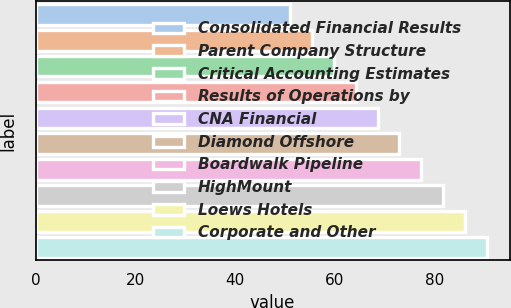<chart> <loc_0><loc_0><loc_500><loc_500><bar_chart><fcel>Consolidated Financial Results<fcel>Parent Company Structure<fcel>Critical Accounting Estimates<fcel>Results of Operations by<fcel>CNA Financial<fcel>Diamond Offshore<fcel>Boardwalk Pipeline<fcel>HighMount<fcel>Loews Hotels<fcel>Corporate and Other<nl><fcel>51<fcel>55.4<fcel>59.8<fcel>64.2<fcel>68.6<fcel>73<fcel>77.4<fcel>81.8<fcel>86.2<fcel>90.6<nl></chart> 